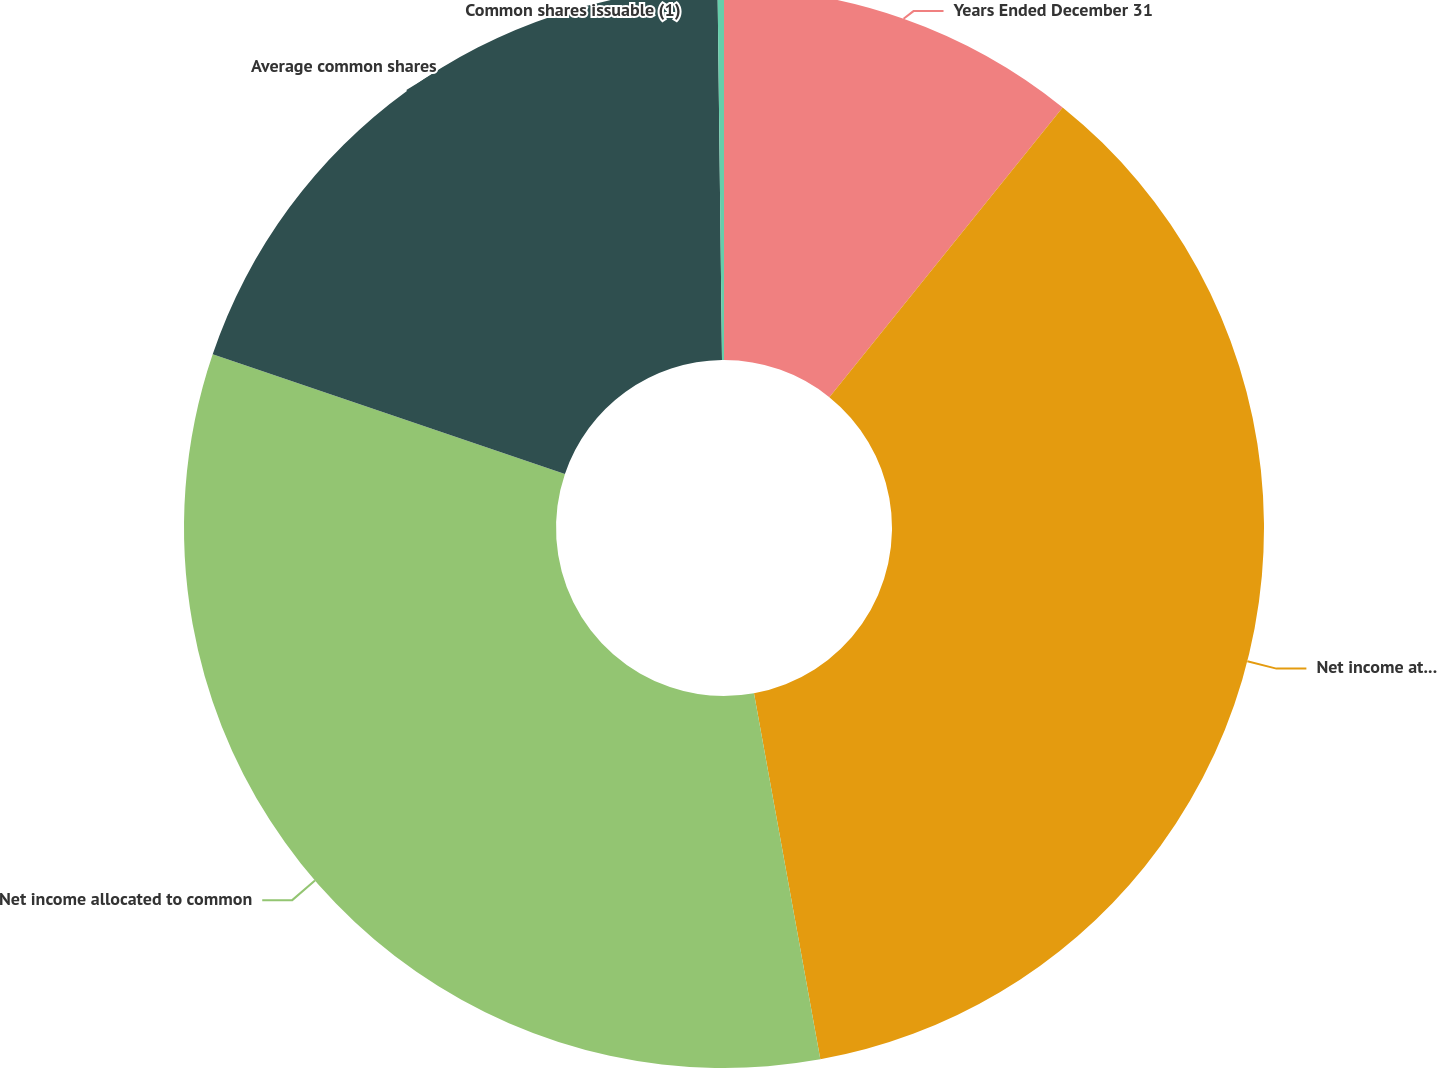<chart> <loc_0><loc_0><loc_500><loc_500><pie_chart><fcel>Years Ended December 31<fcel>Net income attributable to<fcel>Net income allocated to common<fcel>Average common shares<fcel>Common shares issuable (1)<nl><fcel>10.79%<fcel>36.36%<fcel>33.07%<fcel>19.6%<fcel>0.19%<nl></chart> 